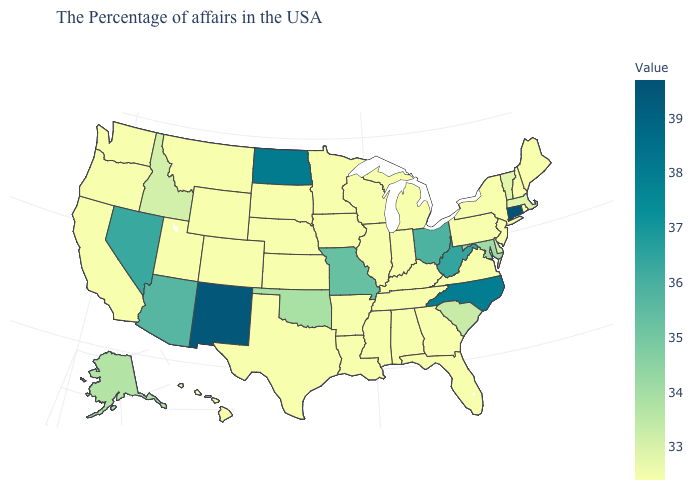Is the legend a continuous bar?
Keep it brief. Yes. Among the states that border Massachusetts , does Connecticut have the lowest value?
Concise answer only. No. Does Florida have the lowest value in the USA?
Write a very short answer. Yes. Does the map have missing data?
Be succinct. No. Among the states that border Arizona , does Nevada have the lowest value?
Quick response, please. No. Which states have the lowest value in the South?
Write a very short answer. Virginia, Florida, Georgia, Kentucky, Alabama, Tennessee, Mississippi, Louisiana, Arkansas, Texas. 